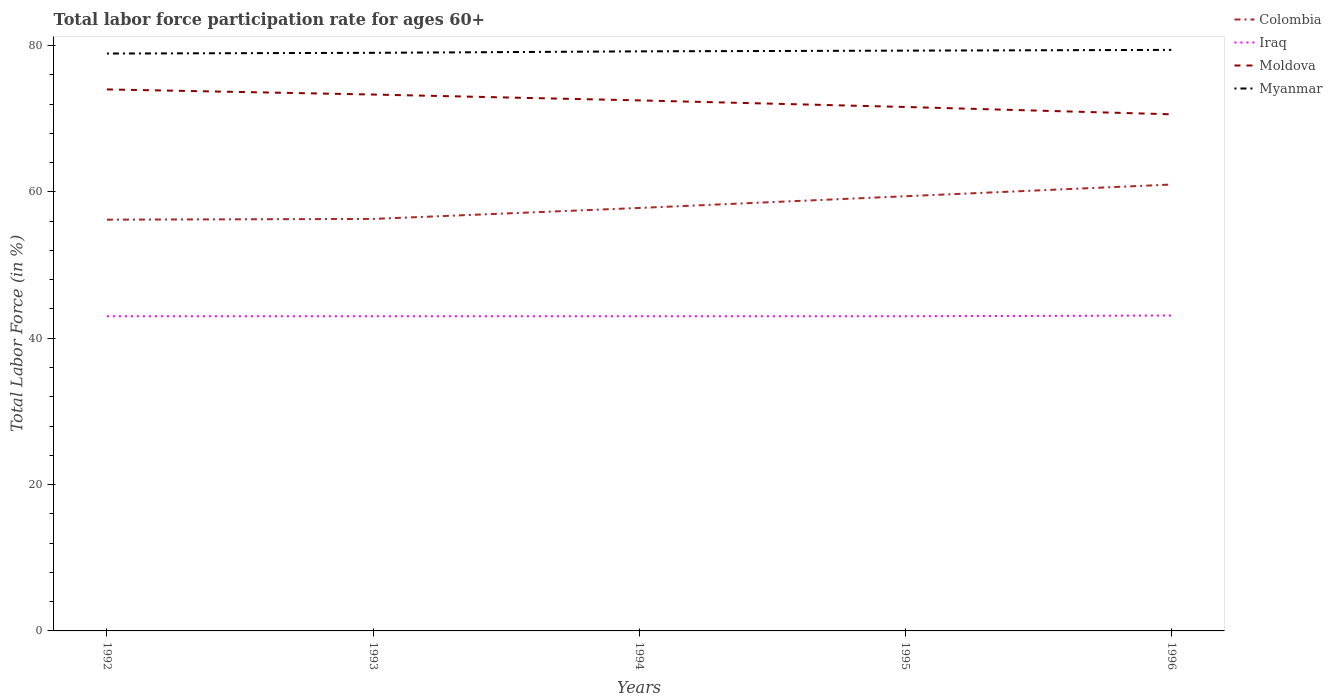Does the line corresponding to Colombia intersect with the line corresponding to Iraq?
Your response must be concise. No. Is the number of lines equal to the number of legend labels?
Your response must be concise. Yes. Across all years, what is the maximum labor force participation rate in Colombia?
Keep it short and to the point. 56.2. In which year was the labor force participation rate in Moldova maximum?
Your answer should be very brief. 1996. What is the total labor force participation rate in Moldova in the graph?
Provide a short and direct response. 2.4. What is the difference between the highest and the second highest labor force participation rate in Colombia?
Offer a very short reply. 4.8. Is the labor force participation rate in Myanmar strictly greater than the labor force participation rate in Moldova over the years?
Your response must be concise. No. How many years are there in the graph?
Your answer should be compact. 5. What is the difference between two consecutive major ticks on the Y-axis?
Your answer should be very brief. 20. Does the graph contain any zero values?
Offer a terse response. No. Does the graph contain grids?
Give a very brief answer. No. Where does the legend appear in the graph?
Make the answer very short. Top right. How are the legend labels stacked?
Your answer should be compact. Vertical. What is the title of the graph?
Make the answer very short. Total labor force participation rate for ages 60+. Does "Korea (Democratic)" appear as one of the legend labels in the graph?
Offer a very short reply. No. What is the label or title of the X-axis?
Your answer should be compact. Years. What is the Total Labor Force (in %) of Colombia in 1992?
Your answer should be compact. 56.2. What is the Total Labor Force (in %) in Moldova in 1992?
Offer a terse response. 74. What is the Total Labor Force (in %) of Myanmar in 1992?
Keep it short and to the point. 78.9. What is the Total Labor Force (in %) in Colombia in 1993?
Make the answer very short. 56.3. What is the Total Labor Force (in %) of Moldova in 1993?
Offer a very short reply. 73.3. What is the Total Labor Force (in %) in Myanmar in 1993?
Your answer should be compact. 79. What is the Total Labor Force (in %) of Colombia in 1994?
Offer a very short reply. 57.8. What is the Total Labor Force (in %) of Moldova in 1994?
Provide a succinct answer. 72.5. What is the Total Labor Force (in %) in Myanmar in 1994?
Give a very brief answer. 79.2. What is the Total Labor Force (in %) in Colombia in 1995?
Your response must be concise. 59.4. What is the Total Labor Force (in %) in Iraq in 1995?
Offer a terse response. 43. What is the Total Labor Force (in %) of Moldova in 1995?
Your response must be concise. 71.6. What is the Total Labor Force (in %) of Myanmar in 1995?
Keep it short and to the point. 79.3. What is the Total Labor Force (in %) in Colombia in 1996?
Provide a succinct answer. 61. What is the Total Labor Force (in %) of Iraq in 1996?
Provide a succinct answer. 43.1. What is the Total Labor Force (in %) of Moldova in 1996?
Keep it short and to the point. 70.6. What is the Total Labor Force (in %) of Myanmar in 1996?
Your response must be concise. 79.4. Across all years, what is the maximum Total Labor Force (in %) in Colombia?
Offer a terse response. 61. Across all years, what is the maximum Total Labor Force (in %) in Iraq?
Make the answer very short. 43.1. Across all years, what is the maximum Total Labor Force (in %) of Myanmar?
Offer a very short reply. 79.4. Across all years, what is the minimum Total Labor Force (in %) of Colombia?
Keep it short and to the point. 56.2. Across all years, what is the minimum Total Labor Force (in %) of Iraq?
Your answer should be compact. 43. Across all years, what is the minimum Total Labor Force (in %) of Moldova?
Offer a very short reply. 70.6. Across all years, what is the minimum Total Labor Force (in %) of Myanmar?
Your answer should be compact. 78.9. What is the total Total Labor Force (in %) in Colombia in the graph?
Your answer should be compact. 290.7. What is the total Total Labor Force (in %) of Iraq in the graph?
Your response must be concise. 215.1. What is the total Total Labor Force (in %) in Moldova in the graph?
Offer a terse response. 362. What is the total Total Labor Force (in %) of Myanmar in the graph?
Ensure brevity in your answer.  395.8. What is the difference between the Total Labor Force (in %) of Colombia in 1992 and that in 1993?
Offer a terse response. -0.1. What is the difference between the Total Labor Force (in %) in Moldova in 1992 and that in 1993?
Offer a very short reply. 0.7. What is the difference between the Total Labor Force (in %) in Colombia in 1992 and that in 1994?
Keep it short and to the point. -1.6. What is the difference between the Total Labor Force (in %) in Moldova in 1992 and that in 1994?
Ensure brevity in your answer.  1.5. What is the difference between the Total Labor Force (in %) in Myanmar in 1992 and that in 1994?
Give a very brief answer. -0.3. What is the difference between the Total Labor Force (in %) in Colombia in 1992 and that in 1995?
Your answer should be very brief. -3.2. What is the difference between the Total Labor Force (in %) of Myanmar in 1992 and that in 1995?
Ensure brevity in your answer.  -0.4. What is the difference between the Total Labor Force (in %) in Colombia in 1992 and that in 1996?
Provide a short and direct response. -4.8. What is the difference between the Total Labor Force (in %) in Moldova in 1993 and that in 1994?
Make the answer very short. 0.8. What is the difference between the Total Labor Force (in %) in Myanmar in 1993 and that in 1994?
Give a very brief answer. -0.2. What is the difference between the Total Labor Force (in %) in Colombia in 1993 and that in 1995?
Ensure brevity in your answer.  -3.1. What is the difference between the Total Labor Force (in %) in Moldova in 1993 and that in 1995?
Provide a succinct answer. 1.7. What is the difference between the Total Labor Force (in %) in Iraq in 1993 and that in 1996?
Offer a terse response. -0.1. What is the difference between the Total Labor Force (in %) of Moldova in 1993 and that in 1996?
Make the answer very short. 2.7. What is the difference between the Total Labor Force (in %) in Moldova in 1994 and that in 1995?
Ensure brevity in your answer.  0.9. What is the difference between the Total Labor Force (in %) of Myanmar in 1994 and that in 1995?
Ensure brevity in your answer.  -0.1. What is the difference between the Total Labor Force (in %) of Iraq in 1994 and that in 1996?
Keep it short and to the point. -0.1. What is the difference between the Total Labor Force (in %) in Myanmar in 1994 and that in 1996?
Give a very brief answer. -0.2. What is the difference between the Total Labor Force (in %) of Colombia in 1995 and that in 1996?
Your answer should be very brief. -1.6. What is the difference between the Total Labor Force (in %) in Iraq in 1995 and that in 1996?
Give a very brief answer. -0.1. What is the difference between the Total Labor Force (in %) of Colombia in 1992 and the Total Labor Force (in %) of Moldova in 1993?
Keep it short and to the point. -17.1. What is the difference between the Total Labor Force (in %) in Colombia in 1992 and the Total Labor Force (in %) in Myanmar in 1993?
Your answer should be very brief. -22.8. What is the difference between the Total Labor Force (in %) in Iraq in 1992 and the Total Labor Force (in %) in Moldova in 1993?
Provide a short and direct response. -30.3. What is the difference between the Total Labor Force (in %) in Iraq in 1992 and the Total Labor Force (in %) in Myanmar in 1993?
Your response must be concise. -36. What is the difference between the Total Labor Force (in %) in Colombia in 1992 and the Total Labor Force (in %) in Iraq in 1994?
Your answer should be very brief. 13.2. What is the difference between the Total Labor Force (in %) of Colombia in 1992 and the Total Labor Force (in %) of Moldova in 1994?
Make the answer very short. -16.3. What is the difference between the Total Labor Force (in %) of Iraq in 1992 and the Total Labor Force (in %) of Moldova in 1994?
Provide a short and direct response. -29.5. What is the difference between the Total Labor Force (in %) of Iraq in 1992 and the Total Labor Force (in %) of Myanmar in 1994?
Offer a terse response. -36.2. What is the difference between the Total Labor Force (in %) of Colombia in 1992 and the Total Labor Force (in %) of Iraq in 1995?
Give a very brief answer. 13.2. What is the difference between the Total Labor Force (in %) of Colombia in 1992 and the Total Labor Force (in %) of Moldova in 1995?
Your answer should be compact. -15.4. What is the difference between the Total Labor Force (in %) of Colombia in 1992 and the Total Labor Force (in %) of Myanmar in 1995?
Provide a short and direct response. -23.1. What is the difference between the Total Labor Force (in %) in Iraq in 1992 and the Total Labor Force (in %) in Moldova in 1995?
Provide a succinct answer. -28.6. What is the difference between the Total Labor Force (in %) of Iraq in 1992 and the Total Labor Force (in %) of Myanmar in 1995?
Your answer should be very brief. -36.3. What is the difference between the Total Labor Force (in %) of Colombia in 1992 and the Total Labor Force (in %) of Iraq in 1996?
Make the answer very short. 13.1. What is the difference between the Total Labor Force (in %) of Colombia in 1992 and the Total Labor Force (in %) of Moldova in 1996?
Provide a short and direct response. -14.4. What is the difference between the Total Labor Force (in %) in Colombia in 1992 and the Total Labor Force (in %) in Myanmar in 1996?
Your answer should be compact. -23.2. What is the difference between the Total Labor Force (in %) in Iraq in 1992 and the Total Labor Force (in %) in Moldova in 1996?
Your response must be concise. -27.6. What is the difference between the Total Labor Force (in %) of Iraq in 1992 and the Total Labor Force (in %) of Myanmar in 1996?
Provide a short and direct response. -36.4. What is the difference between the Total Labor Force (in %) of Colombia in 1993 and the Total Labor Force (in %) of Moldova in 1994?
Provide a succinct answer. -16.2. What is the difference between the Total Labor Force (in %) of Colombia in 1993 and the Total Labor Force (in %) of Myanmar in 1994?
Your answer should be very brief. -22.9. What is the difference between the Total Labor Force (in %) of Iraq in 1993 and the Total Labor Force (in %) of Moldova in 1994?
Keep it short and to the point. -29.5. What is the difference between the Total Labor Force (in %) in Iraq in 1993 and the Total Labor Force (in %) in Myanmar in 1994?
Ensure brevity in your answer.  -36.2. What is the difference between the Total Labor Force (in %) in Colombia in 1993 and the Total Labor Force (in %) in Iraq in 1995?
Offer a terse response. 13.3. What is the difference between the Total Labor Force (in %) in Colombia in 1993 and the Total Labor Force (in %) in Moldova in 1995?
Keep it short and to the point. -15.3. What is the difference between the Total Labor Force (in %) in Colombia in 1993 and the Total Labor Force (in %) in Myanmar in 1995?
Your answer should be very brief. -23. What is the difference between the Total Labor Force (in %) of Iraq in 1993 and the Total Labor Force (in %) of Moldova in 1995?
Make the answer very short. -28.6. What is the difference between the Total Labor Force (in %) in Iraq in 1993 and the Total Labor Force (in %) in Myanmar in 1995?
Provide a succinct answer. -36.3. What is the difference between the Total Labor Force (in %) in Colombia in 1993 and the Total Labor Force (in %) in Moldova in 1996?
Make the answer very short. -14.3. What is the difference between the Total Labor Force (in %) of Colombia in 1993 and the Total Labor Force (in %) of Myanmar in 1996?
Give a very brief answer. -23.1. What is the difference between the Total Labor Force (in %) in Iraq in 1993 and the Total Labor Force (in %) in Moldova in 1996?
Provide a short and direct response. -27.6. What is the difference between the Total Labor Force (in %) in Iraq in 1993 and the Total Labor Force (in %) in Myanmar in 1996?
Your answer should be very brief. -36.4. What is the difference between the Total Labor Force (in %) of Moldova in 1993 and the Total Labor Force (in %) of Myanmar in 1996?
Your answer should be compact. -6.1. What is the difference between the Total Labor Force (in %) in Colombia in 1994 and the Total Labor Force (in %) in Myanmar in 1995?
Offer a terse response. -21.5. What is the difference between the Total Labor Force (in %) in Iraq in 1994 and the Total Labor Force (in %) in Moldova in 1995?
Offer a very short reply. -28.6. What is the difference between the Total Labor Force (in %) of Iraq in 1994 and the Total Labor Force (in %) of Myanmar in 1995?
Ensure brevity in your answer.  -36.3. What is the difference between the Total Labor Force (in %) of Colombia in 1994 and the Total Labor Force (in %) of Moldova in 1996?
Make the answer very short. -12.8. What is the difference between the Total Labor Force (in %) of Colombia in 1994 and the Total Labor Force (in %) of Myanmar in 1996?
Your answer should be compact. -21.6. What is the difference between the Total Labor Force (in %) in Iraq in 1994 and the Total Labor Force (in %) in Moldova in 1996?
Your answer should be compact. -27.6. What is the difference between the Total Labor Force (in %) in Iraq in 1994 and the Total Labor Force (in %) in Myanmar in 1996?
Your answer should be compact. -36.4. What is the difference between the Total Labor Force (in %) in Moldova in 1994 and the Total Labor Force (in %) in Myanmar in 1996?
Provide a succinct answer. -6.9. What is the difference between the Total Labor Force (in %) of Colombia in 1995 and the Total Labor Force (in %) of Iraq in 1996?
Offer a very short reply. 16.3. What is the difference between the Total Labor Force (in %) in Colombia in 1995 and the Total Labor Force (in %) in Moldova in 1996?
Offer a very short reply. -11.2. What is the difference between the Total Labor Force (in %) in Iraq in 1995 and the Total Labor Force (in %) in Moldova in 1996?
Offer a very short reply. -27.6. What is the difference between the Total Labor Force (in %) in Iraq in 1995 and the Total Labor Force (in %) in Myanmar in 1996?
Offer a very short reply. -36.4. What is the difference between the Total Labor Force (in %) in Moldova in 1995 and the Total Labor Force (in %) in Myanmar in 1996?
Offer a terse response. -7.8. What is the average Total Labor Force (in %) of Colombia per year?
Provide a succinct answer. 58.14. What is the average Total Labor Force (in %) in Iraq per year?
Provide a succinct answer. 43.02. What is the average Total Labor Force (in %) in Moldova per year?
Your answer should be compact. 72.4. What is the average Total Labor Force (in %) of Myanmar per year?
Make the answer very short. 79.16. In the year 1992, what is the difference between the Total Labor Force (in %) of Colombia and Total Labor Force (in %) of Moldova?
Give a very brief answer. -17.8. In the year 1992, what is the difference between the Total Labor Force (in %) in Colombia and Total Labor Force (in %) in Myanmar?
Ensure brevity in your answer.  -22.7. In the year 1992, what is the difference between the Total Labor Force (in %) of Iraq and Total Labor Force (in %) of Moldova?
Offer a terse response. -31. In the year 1992, what is the difference between the Total Labor Force (in %) in Iraq and Total Labor Force (in %) in Myanmar?
Offer a very short reply. -35.9. In the year 1992, what is the difference between the Total Labor Force (in %) in Moldova and Total Labor Force (in %) in Myanmar?
Give a very brief answer. -4.9. In the year 1993, what is the difference between the Total Labor Force (in %) of Colombia and Total Labor Force (in %) of Iraq?
Make the answer very short. 13.3. In the year 1993, what is the difference between the Total Labor Force (in %) in Colombia and Total Labor Force (in %) in Moldova?
Provide a short and direct response. -17. In the year 1993, what is the difference between the Total Labor Force (in %) in Colombia and Total Labor Force (in %) in Myanmar?
Offer a terse response. -22.7. In the year 1993, what is the difference between the Total Labor Force (in %) of Iraq and Total Labor Force (in %) of Moldova?
Your answer should be very brief. -30.3. In the year 1993, what is the difference between the Total Labor Force (in %) in Iraq and Total Labor Force (in %) in Myanmar?
Offer a very short reply. -36. In the year 1994, what is the difference between the Total Labor Force (in %) of Colombia and Total Labor Force (in %) of Moldova?
Offer a very short reply. -14.7. In the year 1994, what is the difference between the Total Labor Force (in %) of Colombia and Total Labor Force (in %) of Myanmar?
Offer a terse response. -21.4. In the year 1994, what is the difference between the Total Labor Force (in %) in Iraq and Total Labor Force (in %) in Moldova?
Offer a terse response. -29.5. In the year 1994, what is the difference between the Total Labor Force (in %) of Iraq and Total Labor Force (in %) of Myanmar?
Keep it short and to the point. -36.2. In the year 1994, what is the difference between the Total Labor Force (in %) of Moldova and Total Labor Force (in %) of Myanmar?
Offer a terse response. -6.7. In the year 1995, what is the difference between the Total Labor Force (in %) in Colombia and Total Labor Force (in %) in Myanmar?
Provide a succinct answer. -19.9. In the year 1995, what is the difference between the Total Labor Force (in %) in Iraq and Total Labor Force (in %) in Moldova?
Offer a terse response. -28.6. In the year 1995, what is the difference between the Total Labor Force (in %) of Iraq and Total Labor Force (in %) of Myanmar?
Make the answer very short. -36.3. In the year 1996, what is the difference between the Total Labor Force (in %) of Colombia and Total Labor Force (in %) of Iraq?
Ensure brevity in your answer.  17.9. In the year 1996, what is the difference between the Total Labor Force (in %) in Colombia and Total Labor Force (in %) in Moldova?
Provide a succinct answer. -9.6. In the year 1996, what is the difference between the Total Labor Force (in %) of Colombia and Total Labor Force (in %) of Myanmar?
Provide a short and direct response. -18.4. In the year 1996, what is the difference between the Total Labor Force (in %) of Iraq and Total Labor Force (in %) of Moldova?
Make the answer very short. -27.5. In the year 1996, what is the difference between the Total Labor Force (in %) of Iraq and Total Labor Force (in %) of Myanmar?
Your answer should be compact. -36.3. In the year 1996, what is the difference between the Total Labor Force (in %) of Moldova and Total Labor Force (in %) of Myanmar?
Make the answer very short. -8.8. What is the ratio of the Total Labor Force (in %) in Colombia in 1992 to that in 1993?
Keep it short and to the point. 1. What is the ratio of the Total Labor Force (in %) in Moldova in 1992 to that in 1993?
Keep it short and to the point. 1.01. What is the ratio of the Total Labor Force (in %) of Colombia in 1992 to that in 1994?
Give a very brief answer. 0.97. What is the ratio of the Total Labor Force (in %) in Moldova in 1992 to that in 1994?
Your answer should be compact. 1.02. What is the ratio of the Total Labor Force (in %) in Colombia in 1992 to that in 1995?
Your answer should be very brief. 0.95. What is the ratio of the Total Labor Force (in %) of Moldova in 1992 to that in 1995?
Provide a succinct answer. 1.03. What is the ratio of the Total Labor Force (in %) in Colombia in 1992 to that in 1996?
Keep it short and to the point. 0.92. What is the ratio of the Total Labor Force (in %) of Moldova in 1992 to that in 1996?
Your answer should be compact. 1.05. What is the ratio of the Total Labor Force (in %) in Myanmar in 1992 to that in 1996?
Keep it short and to the point. 0.99. What is the ratio of the Total Labor Force (in %) in Iraq in 1993 to that in 1994?
Make the answer very short. 1. What is the ratio of the Total Labor Force (in %) in Moldova in 1993 to that in 1994?
Ensure brevity in your answer.  1.01. What is the ratio of the Total Labor Force (in %) in Colombia in 1993 to that in 1995?
Keep it short and to the point. 0.95. What is the ratio of the Total Labor Force (in %) of Moldova in 1993 to that in 1995?
Your answer should be very brief. 1.02. What is the ratio of the Total Labor Force (in %) in Myanmar in 1993 to that in 1995?
Offer a terse response. 1. What is the ratio of the Total Labor Force (in %) in Colombia in 1993 to that in 1996?
Offer a very short reply. 0.92. What is the ratio of the Total Labor Force (in %) in Iraq in 1993 to that in 1996?
Offer a terse response. 1. What is the ratio of the Total Labor Force (in %) in Moldova in 1993 to that in 1996?
Make the answer very short. 1.04. What is the ratio of the Total Labor Force (in %) of Myanmar in 1993 to that in 1996?
Your response must be concise. 0.99. What is the ratio of the Total Labor Force (in %) of Colombia in 1994 to that in 1995?
Offer a terse response. 0.97. What is the ratio of the Total Labor Force (in %) in Iraq in 1994 to that in 1995?
Offer a terse response. 1. What is the ratio of the Total Labor Force (in %) of Moldova in 1994 to that in 1995?
Offer a very short reply. 1.01. What is the ratio of the Total Labor Force (in %) in Myanmar in 1994 to that in 1995?
Your answer should be compact. 1. What is the ratio of the Total Labor Force (in %) of Colombia in 1994 to that in 1996?
Provide a short and direct response. 0.95. What is the ratio of the Total Labor Force (in %) of Moldova in 1994 to that in 1996?
Your answer should be compact. 1.03. What is the ratio of the Total Labor Force (in %) of Myanmar in 1994 to that in 1996?
Give a very brief answer. 1. What is the ratio of the Total Labor Force (in %) in Colombia in 1995 to that in 1996?
Offer a very short reply. 0.97. What is the ratio of the Total Labor Force (in %) of Moldova in 1995 to that in 1996?
Provide a succinct answer. 1.01. What is the difference between the highest and the second highest Total Labor Force (in %) of Colombia?
Ensure brevity in your answer.  1.6. What is the difference between the highest and the second highest Total Labor Force (in %) of Moldova?
Keep it short and to the point. 0.7. What is the difference between the highest and the lowest Total Labor Force (in %) of Colombia?
Provide a short and direct response. 4.8. What is the difference between the highest and the lowest Total Labor Force (in %) in Iraq?
Offer a terse response. 0.1. 